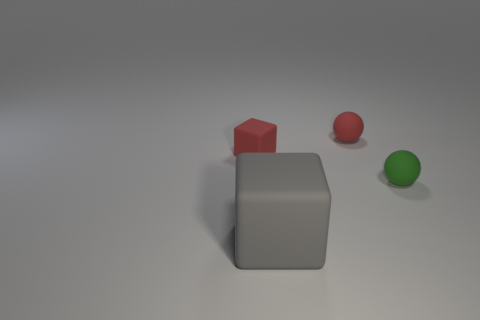Add 3 big things. How many objects exist? 7 Subtract all tiny red cubes. Subtract all big blocks. How many objects are left? 2 Add 2 small objects. How many small objects are left? 5 Add 1 matte spheres. How many matte spheres exist? 3 Subtract 1 gray blocks. How many objects are left? 3 